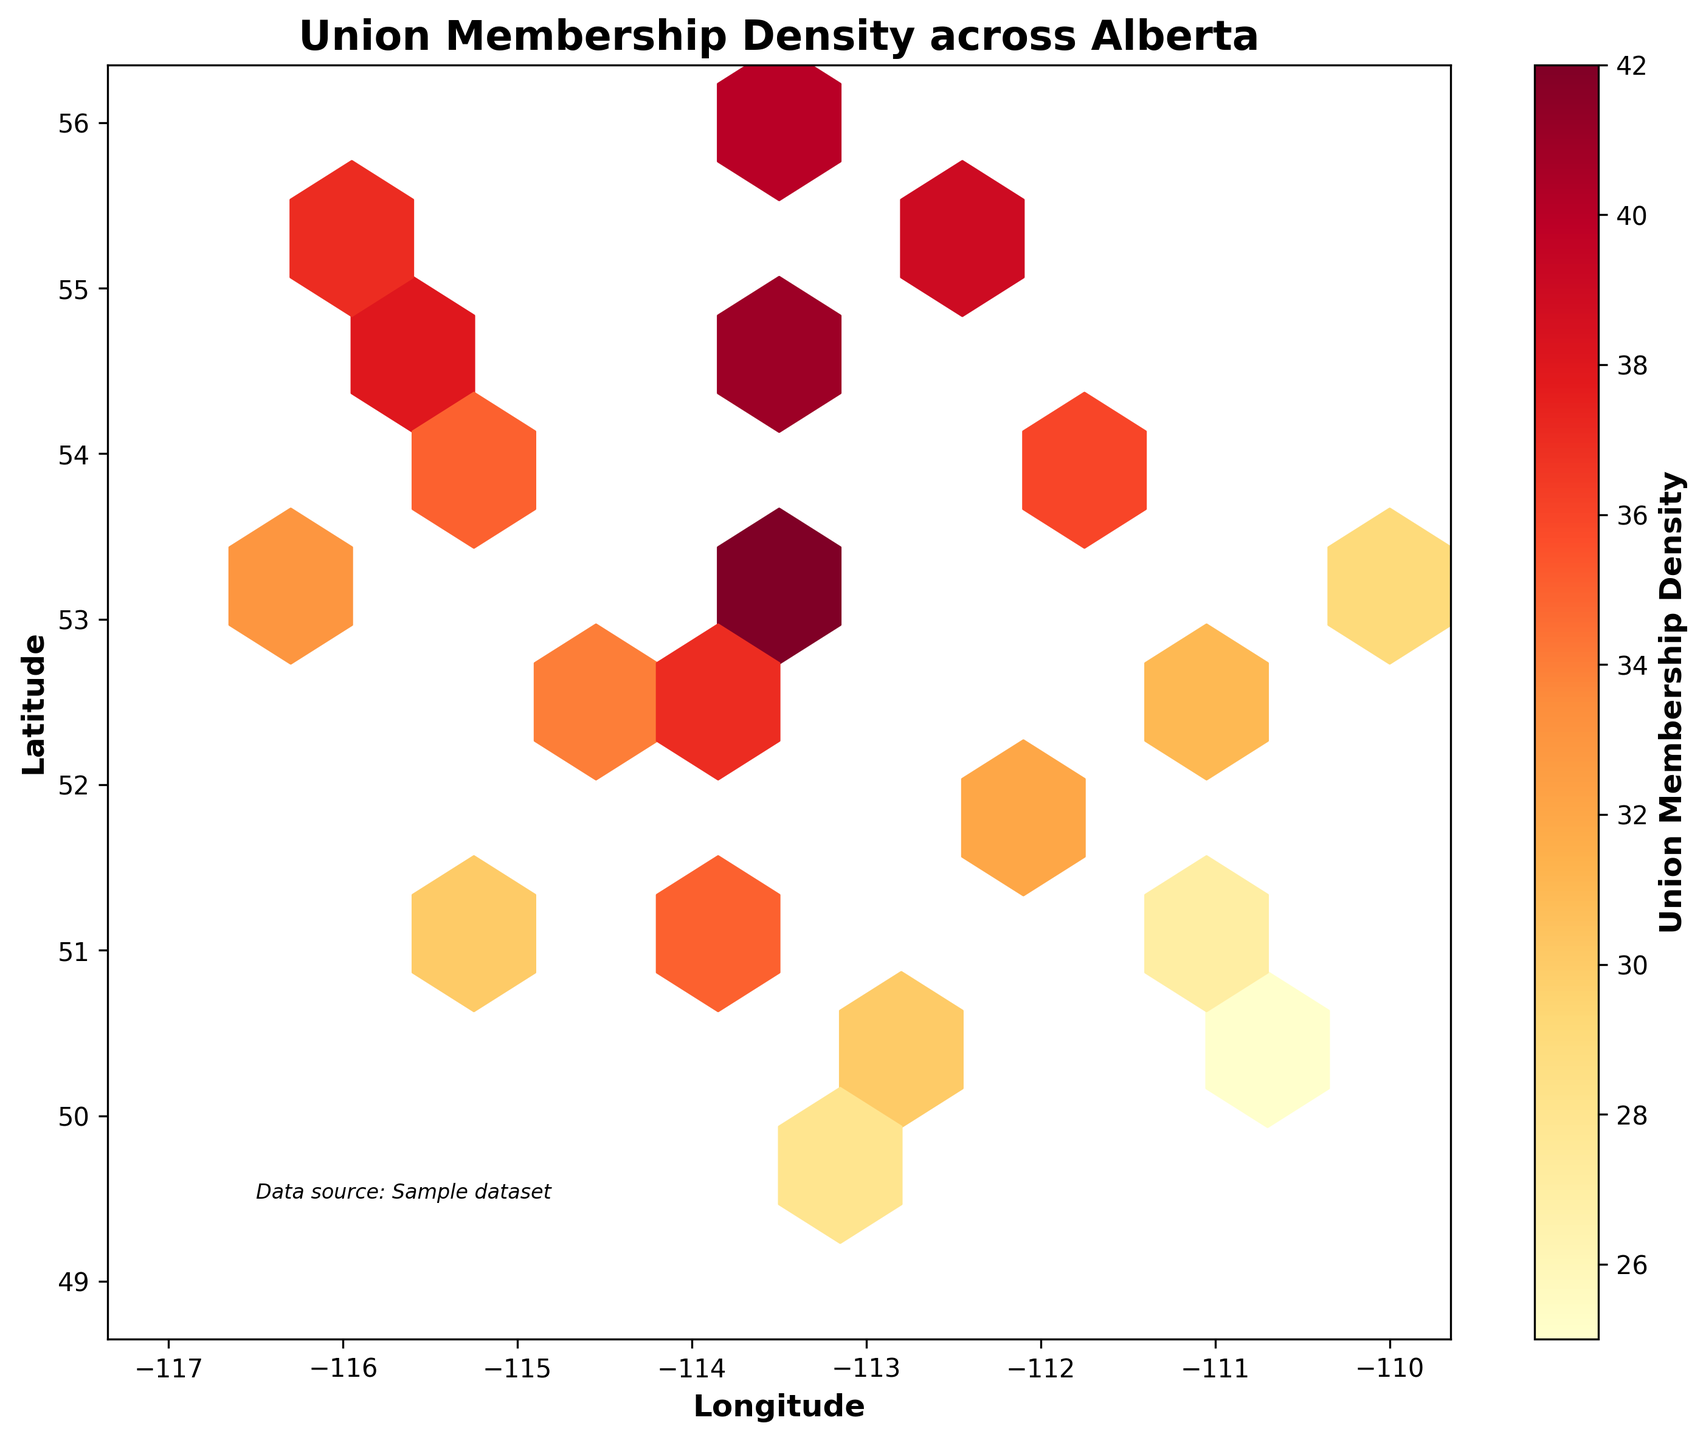What is the title of the hexbin plot? The title of the hexbin plot is typically displayed at the top center of the figure. In this case, it states "Union Membership Density across Alberta". This text indicates what the plot is about.
Answer: Union Membership Density across Alberta What does the color indicate in the hexbin plot? In the hexbin plot, a color gradient is used to represent different values. Specifically, in this plot, shades of the 'YlOrRd' color map are used to indicate "Union Membership Density," as labeled on the color bar. Darker shades correspond to higher densities.
Answer: Union Membership Density What are the coordinates with the highest union membership density? To find the coordinates with the highest density, observe the darkest hexagons in the plot. The darkest region corresponds to the highest density value from the color bar.
Answer: -113.5017, 53.5444 What region has the lowest union membership density? The lowest density regions are identified by the lightest hexagons in the plot. Looking at the color map, the hexagons that are the lightest yellow represent the lowest densities.
Answer: -110.6778, 50.0343 What does the color bar label show? The color bar label is located next to the color bar usually positioned on the side of the plot. It indicates what the color gradient represents. In our case, it labels "Union Membership Density".
Answer: Union Membership Density How many major hexagonal bins can you identify visually? By observing the plot, count the number of large, visually distinct hexagonal bins that appear in different colors. This requires visual estimation.
Answer: 10 Which coordinates have a union membership density of approximately 33? Locate the hexbin color on the plot corresponding to a density of around 33 by checking against the color bar. Identifying the central coordinates of such hexagons will provide the answer.
Answer: -116.5765, 52.9691 Is there a visible pattern or clustering of high union membership densities? Look for areas where darker hexagons, indicating higher densities, are concentrated on the plot. Identifying these clusters reveals patterns.
Answer: Yes, around central Alberta Which region is more unionized, the northern or southern part of Alberta? Compare the density of union memberships represented by color gradients in the northern and southern halves of the plot. See which half has more dark-colored hexagons.
Answer: Northern part What are the axis labels in the hexbin plot? The axis labels can be found at the bottom and left side of the plot. They describe what each axis represents: the horizontal (x-axis) and vertical (y-axis) values.
Answer: Longitude (x-axis), Latitude (y-axis) 